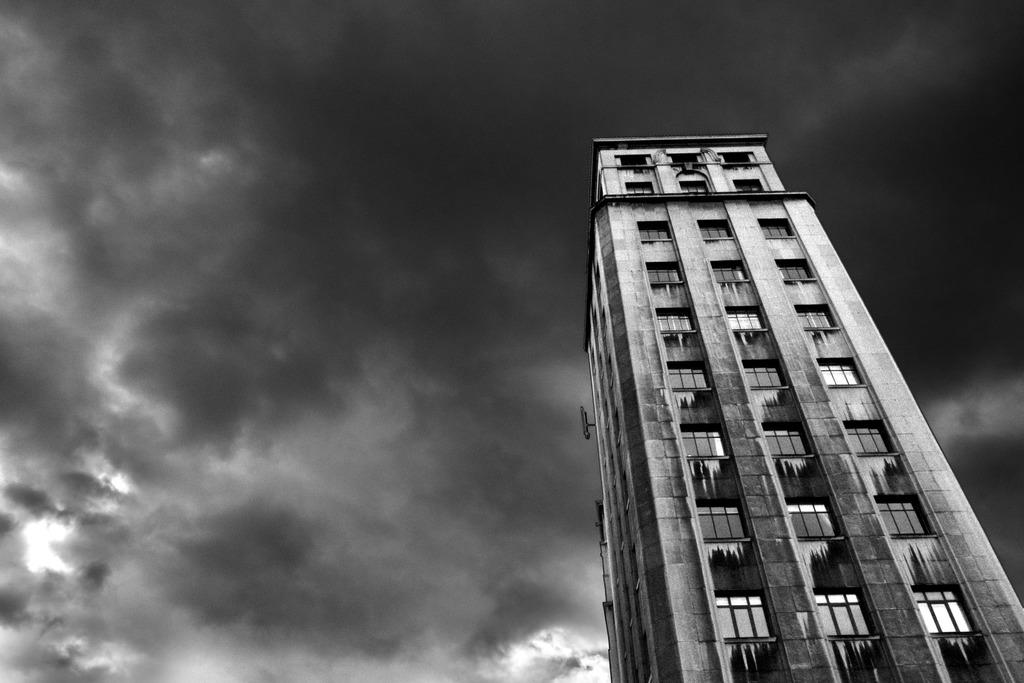What is the color scheme of the image? The image is black and white. What type of structure can be seen in the image? There is a building in the image. What part of the natural environment is visible in the image? The sky is visible in the background of the image. Where is the clover located in the image? There is no clover present in the image. What type of mailbox can be seen near the building in the image? There is no mailbox visible in the image. 